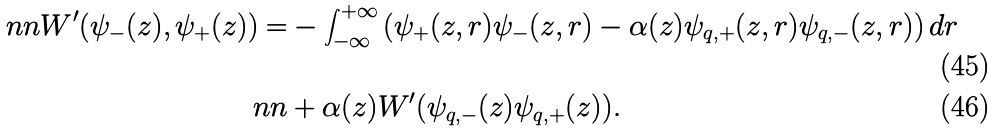Convert formula to latex. <formula><loc_0><loc_0><loc_500><loc_500>\ n n W ^ { \prime } ( \psi _ { - } ( z ) , \psi _ { + } ( z ) ) = & - \int _ { - \infty } ^ { + \infty } \left ( \psi _ { + } ( z , r ) \psi _ { - } ( z , r ) - \alpha ( z ) \psi _ { q , + } ( z , r ) \psi _ { q , - } ( z , r ) \right ) d r \\ \ n n & + \alpha ( z ) W ^ { \prime } ( \psi _ { q , - } ( z ) \psi _ { q , + } ( z ) ) .</formula> 